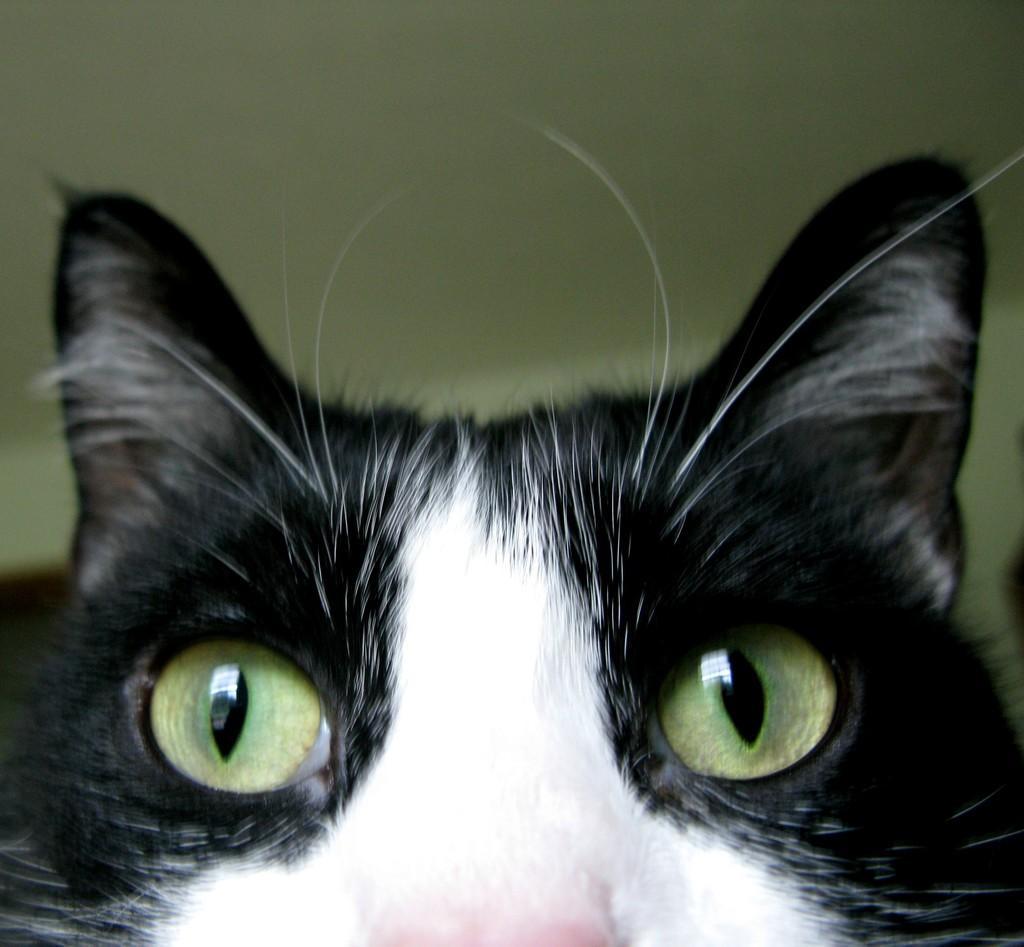Can you describe this image briefly? In this image in the foreground there is one cat, and in the background there is a wall. 